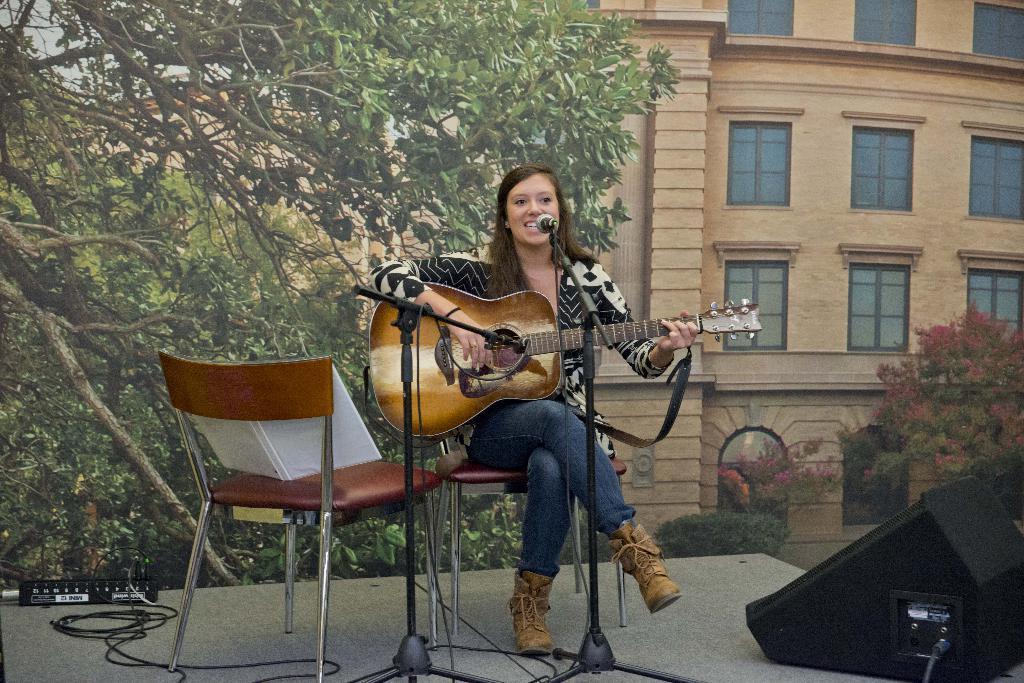Could you give a brief overview of what you see in this image? In the center we can see one woman sitting and holding guitar,in front there is a microphone. In the background we can see building,window,trees,recorder,chair,plant and speaker. 